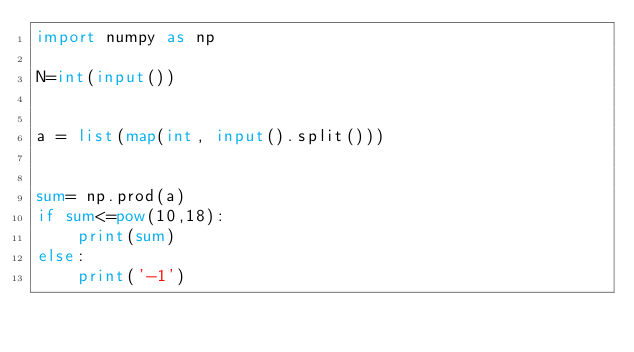<code> <loc_0><loc_0><loc_500><loc_500><_Python_>import numpy as np

N=int(input())


a = list(map(int, input().split()))


sum= np.prod(a)
if sum<=pow(10,18):
    print(sum)
else:
    print('-1')
</code> 